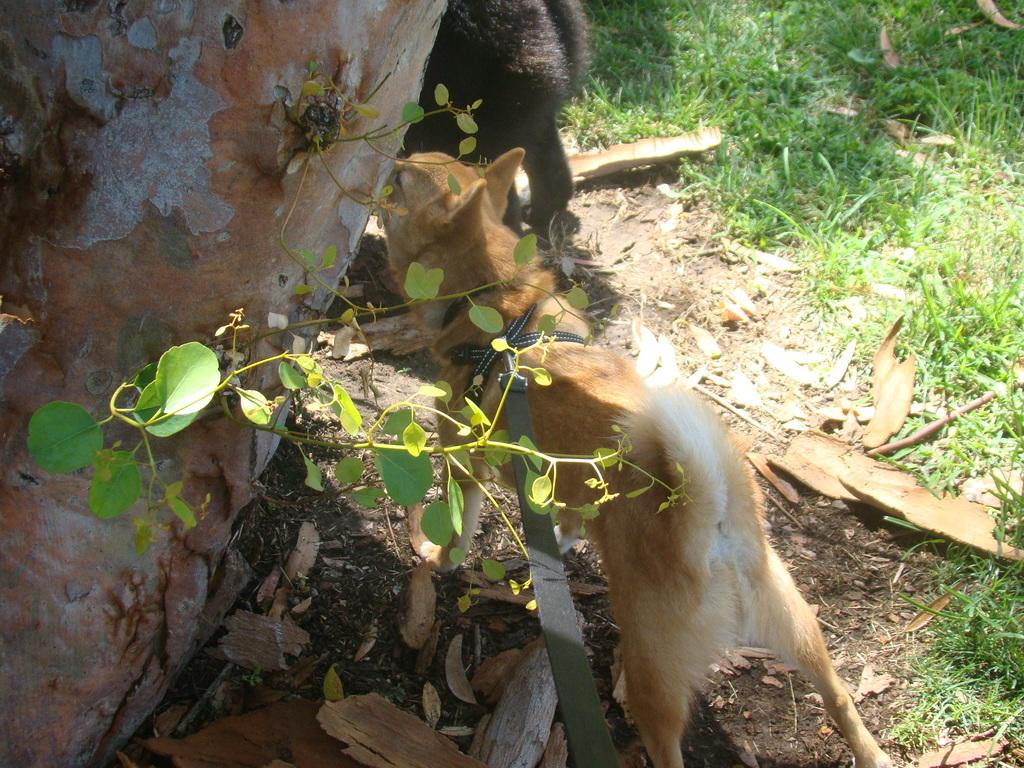What is the main subject of the image? The main subject of the image is a dog standing on the ground. What is attached to the dog's body? A belt is tied to the dog's body. What can be seen on the left side of the image? There is a truncated tree on the left side of the image. What type of animal is visible in the image? There is an animal visible in the image, which is the dog. What is the ground covered with? Grass and leaves are present on the ground. What type of mask is the sun wearing in the image? There is no sun or mask present in the image. 